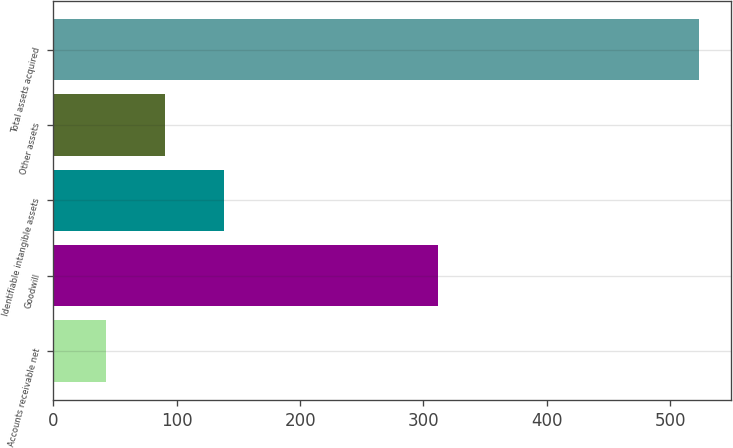Convert chart to OTSL. <chart><loc_0><loc_0><loc_500><loc_500><bar_chart><fcel>Accounts receivable net<fcel>Goodwill<fcel>Identifiable intangible assets<fcel>Other assets<fcel>Total assets acquired<nl><fcel>42.5<fcel>311.7<fcel>138.64<fcel>90.57<fcel>523.2<nl></chart> 